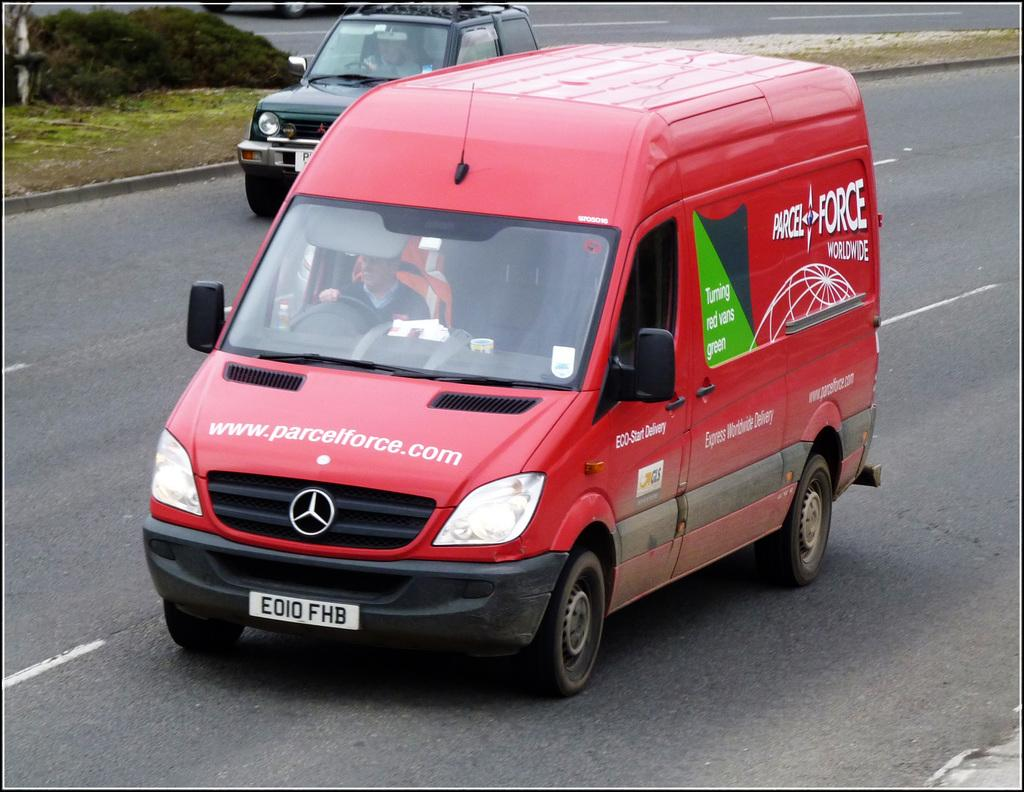<image>
Summarize the visual content of the image. A red Mercedes van for Parcel Force Worldwide drives down the road. 